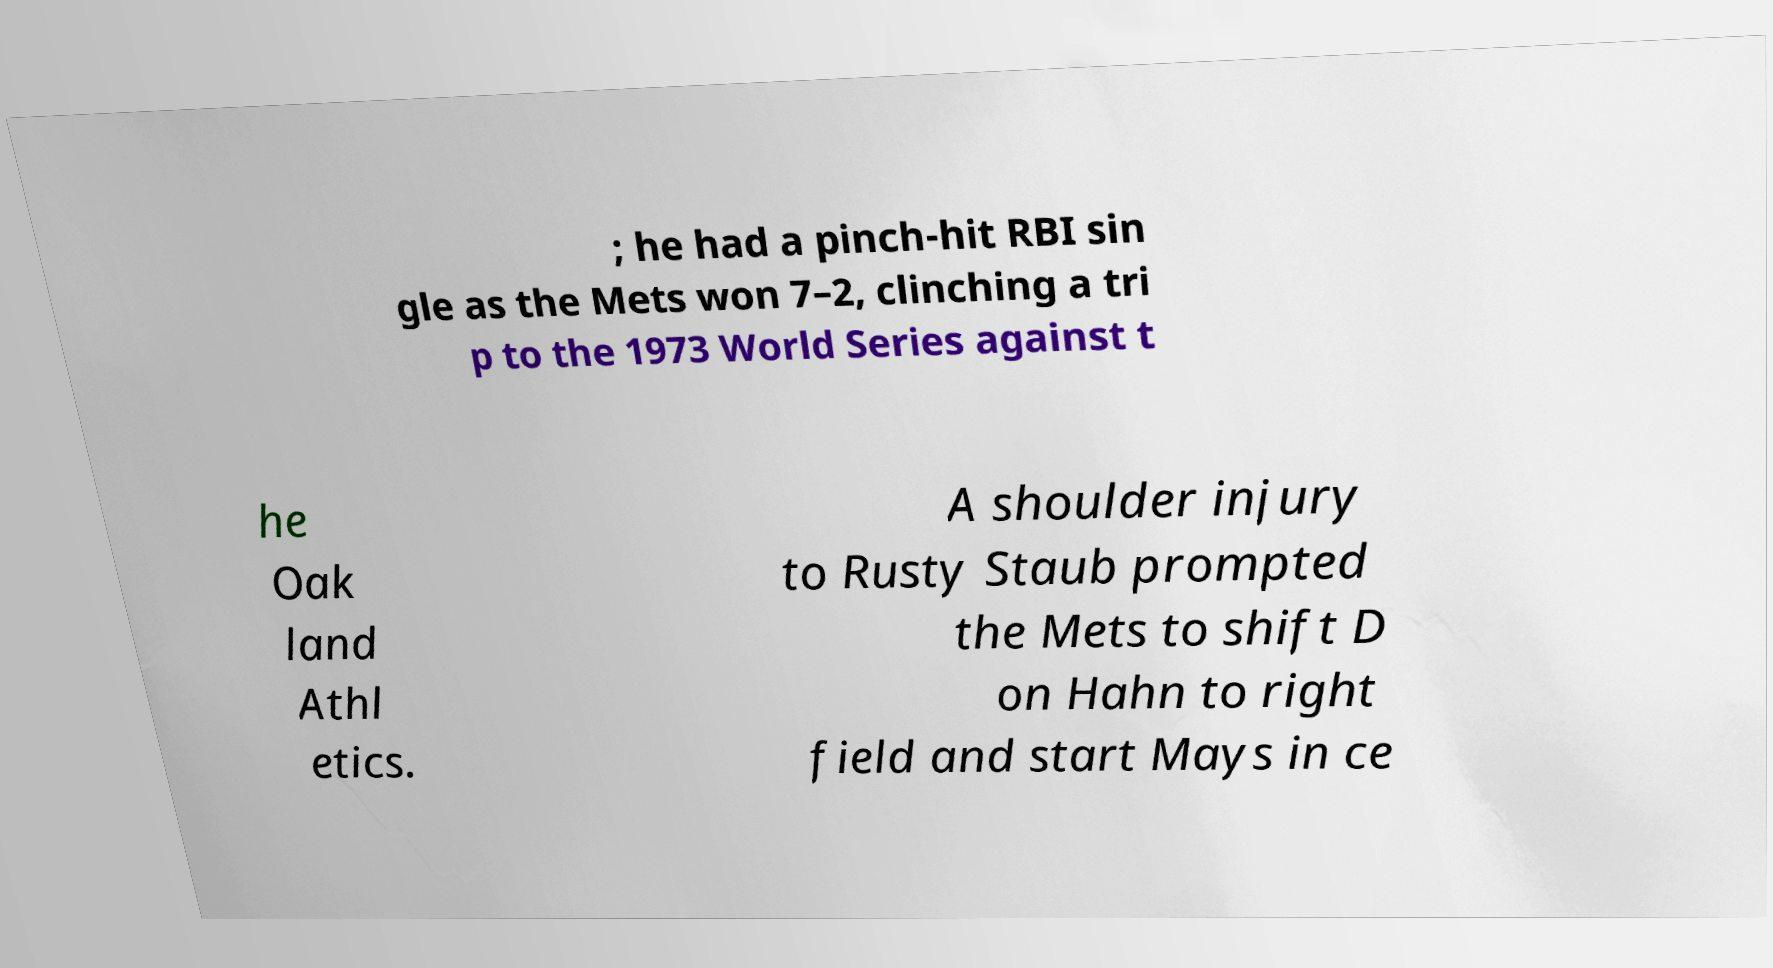For documentation purposes, I need the text within this image transcribed. Could you provide that? ; he had a pinch-hit RBI sin gle as the Mets won 7–2, clinching a tri p to the 1973 World Series against t he Oak land Athl etics. A shoulder injury to Rusty Staub prompted the Mets to shift D on Hahn to right field and start Mays in ce 